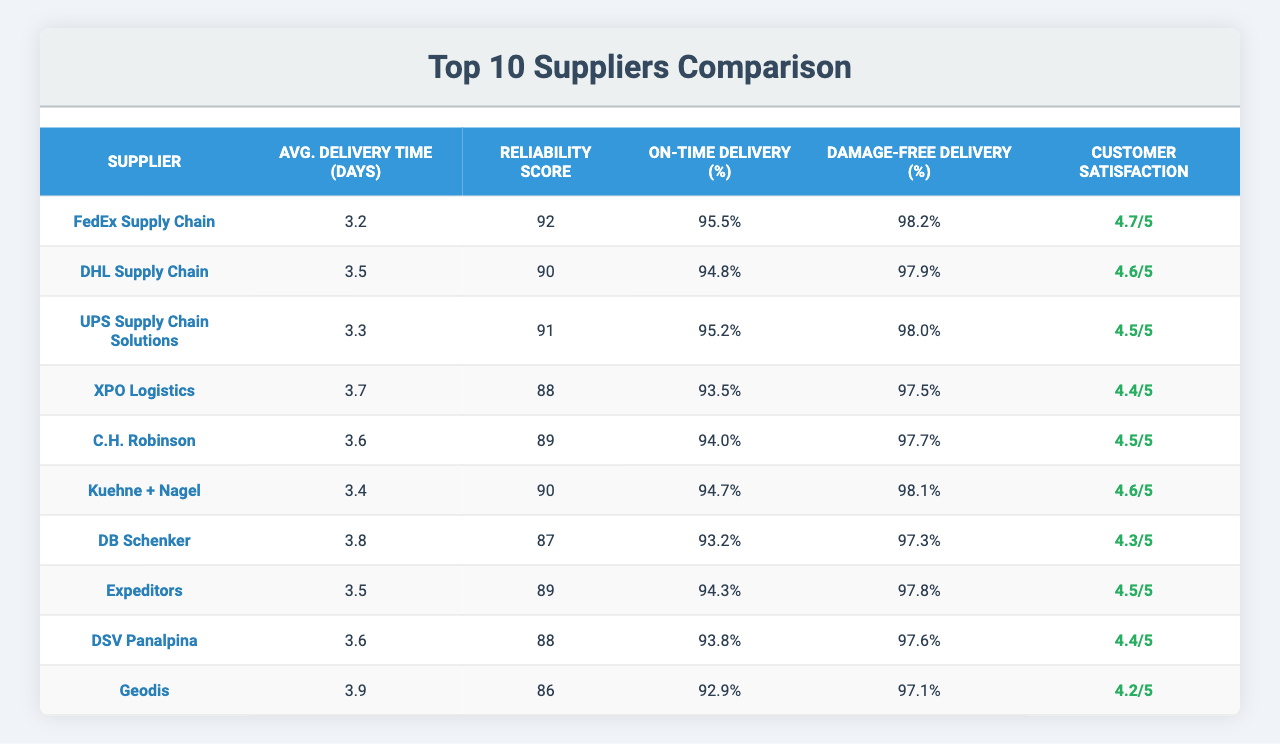What is the average delivery time for FedEx Supply Chain? The table shows that FedEx Supply Chain has an average delivery time of 3.2 days.
Answer: 3.2 days Which supplier has the highest reliability score? By comparing the reliability scores in the table, FedEx Supply Chain has the highest score at 92.
Answer: FedEx Supply Chain What is the on-time delivery percentage of XPO Logistics? The table lists XPO Logistics with an on-time delivery percentage of 93.5%.
Answer: 93.5% How many suppliers have an average delivery time of 3.5 days? The table shows that both DHL Supply Chain and Expeditors have an average delivery time of 3.5 days, making it 2 suppliers.
Answer: 2 suppliers What is the difference in reliability scores between DB Schenker and Geodis? DB Schenker has a reliability score of 87, while Geodis has a score of 86. Thus, the difference is 87 - 86 = 1.
Answer: 1 Which supplier has a higher damage-free delivery percentage: Kuehne + Nagel or C.H. Robinson? Kuehne + Nagel has a damage-free delivery percentage of 98.1%, and C.H. Robinson has 97.7%. Since 98.1% is greater, Kuehne + Nagel is the answer.
Answer: Kuehne + Nagel Is the customer satisfaction rating of FedEx Supply Chain higher than 4.5? The table shows that FedEx Supply Chain has a customer satisfaction rating of 4.7, which is indeed higher than 4.5.
Answer: Yes What are the average delivery times for the top three suppliers? The average delivery times for the top three suppliers are: FedEx Supply Chain (3.2 days), UPS Supply Chain Solutions (3.3 days), and DHL Supply Chain (3.5 days). To find the average: (3.2 + 3.3 + 3.5) / 3 = 3.33 days.
Answer: 3.33 days Which supplier has the lowest customer satisfaction rating? Geodis has the lowest customer satisfaction rating listed in the table at 4.2.
Answer: Geodis If we consider the average delivery times of all suppliers, what is the range? The highest average delivery time is for Geodis (3.9 days) and the lowest is for FedEx Supply Chain (3.2 days). The range is 3.9 - 3.2 = 0.7 days.
Answer: 0.7 days 